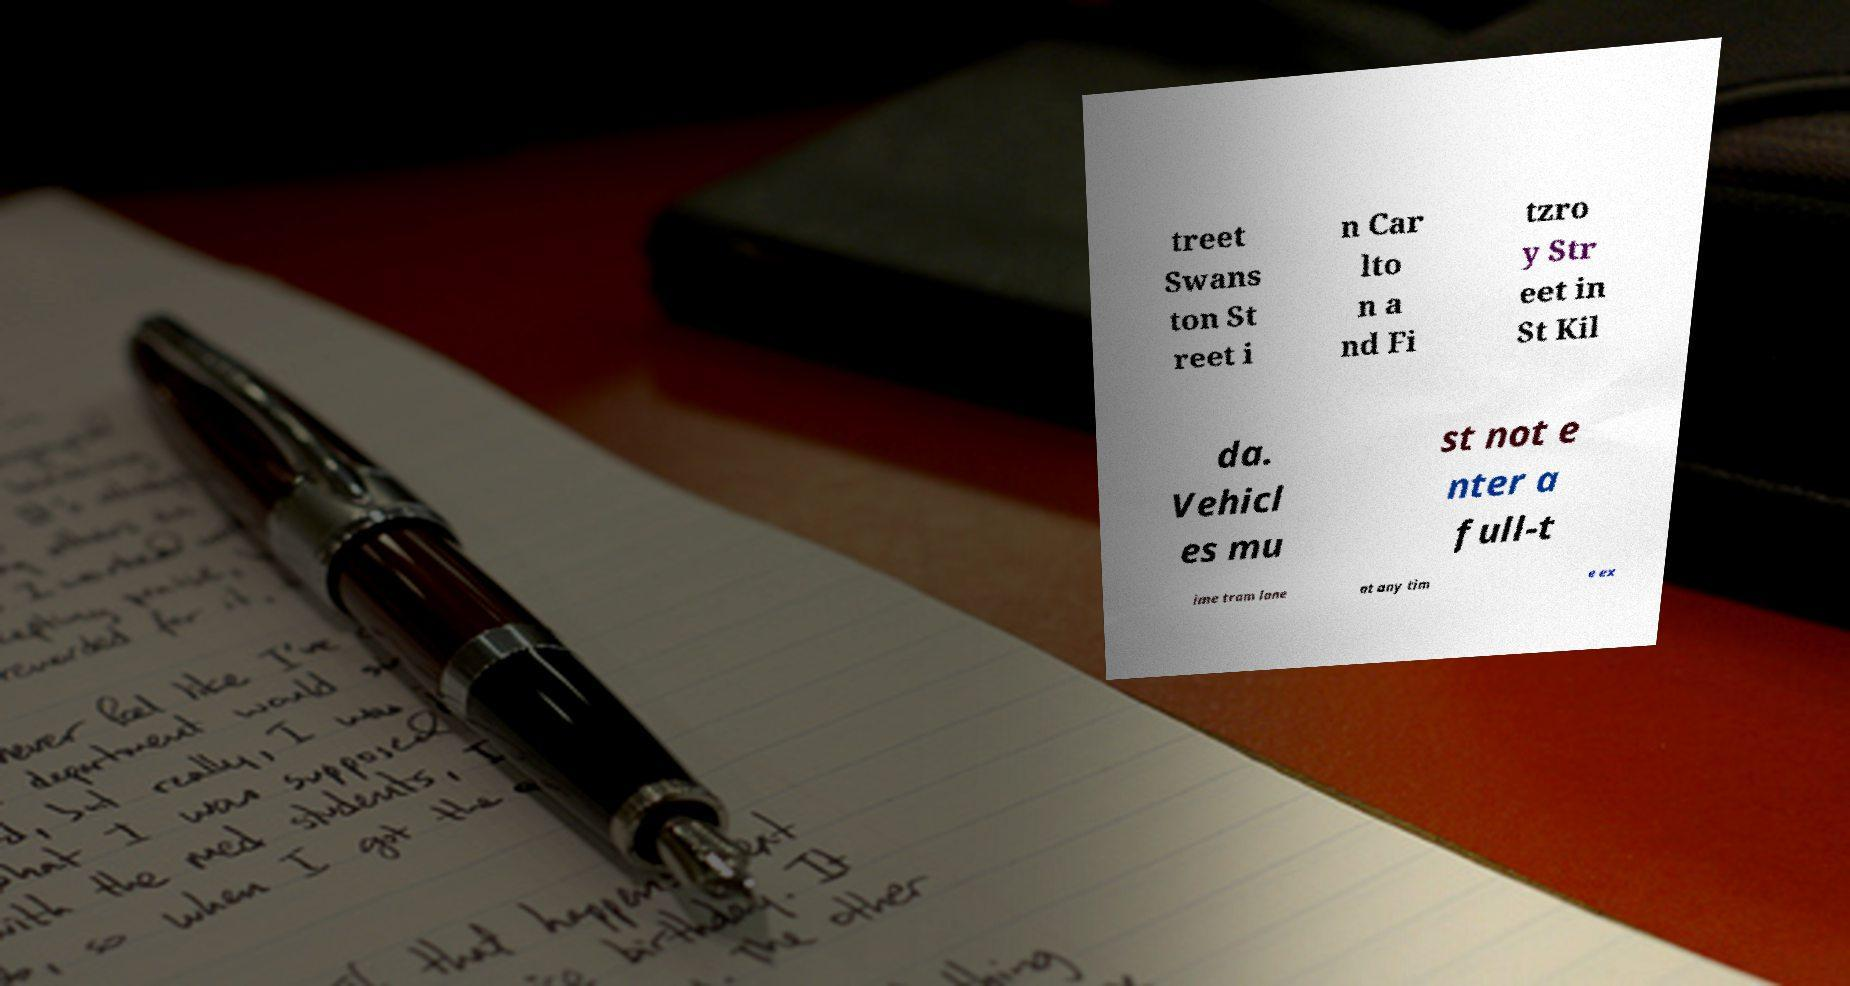What messages or text are displayed in this image? I need them in a readable, typed format. treet Swans ton St reet i n Car lto n a nd Fi tzro y Str eet in St Kil da. Vehicl es mu st not e nter a full-t ime tram lane at any tim e ex 